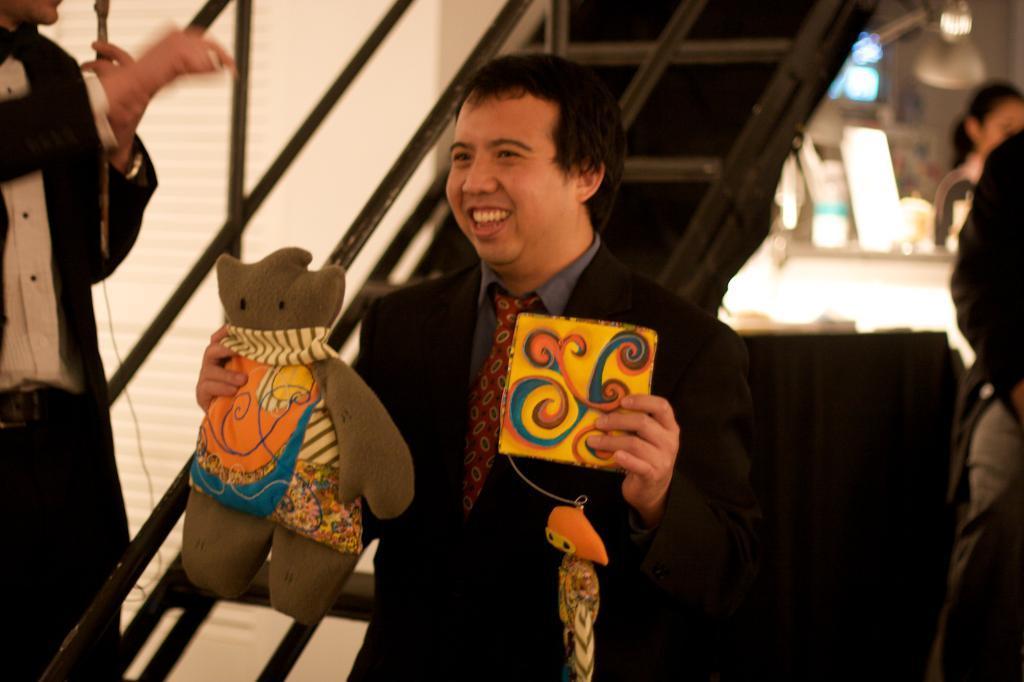Describe this image in one or two sentences. In this image we can see group of people standing on the ground. One person wearing black coat and a tie is holding two toys in his hand. In the background we can see a staircase and group of lights. 